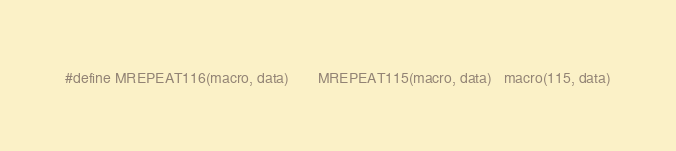Convert code to text. <code><loc_0><loc_0><loc_500><loc_500><_C_>#define MREPEAT116(macro, data)       MREPEAT115(macro, data)   macro(115, data)</code> 